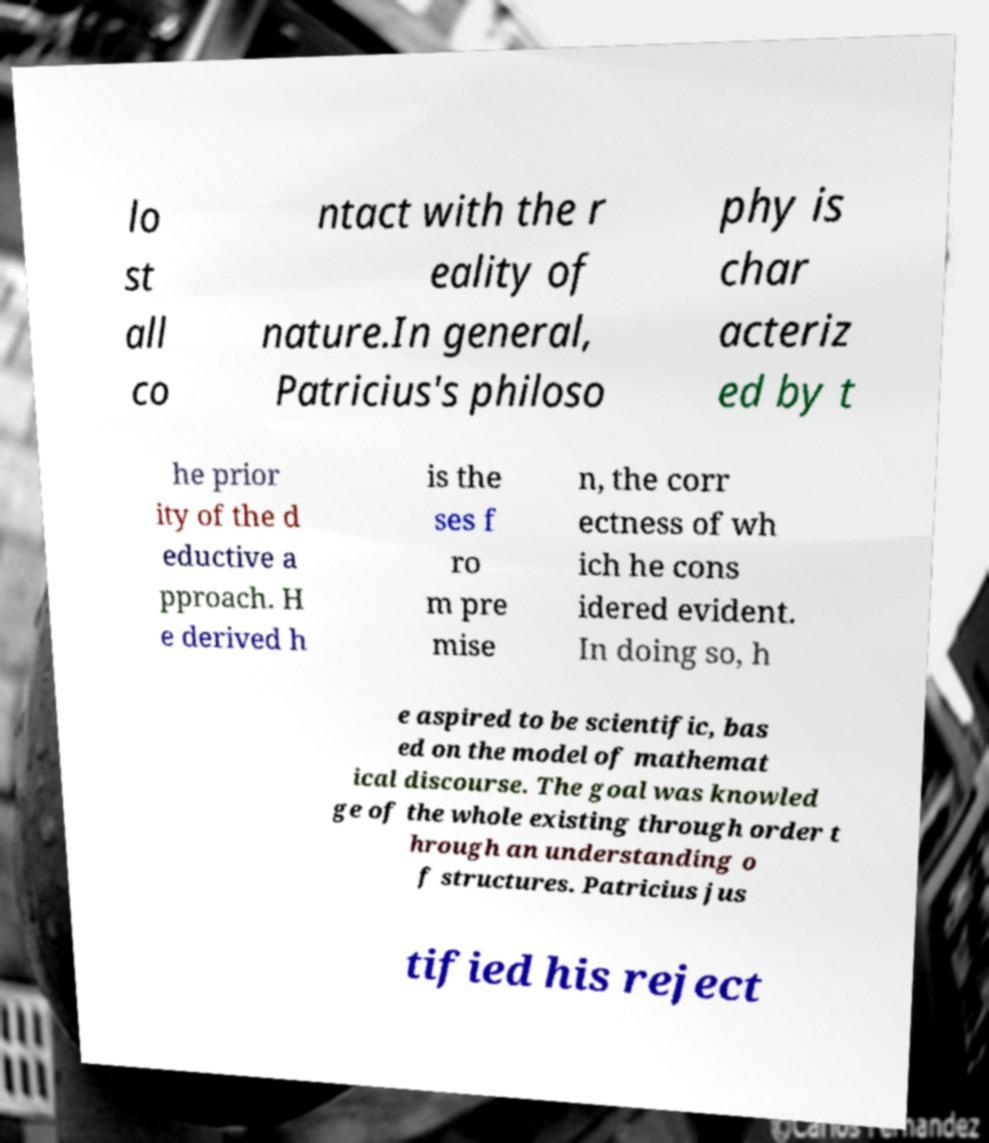I need the written content from this picture converted into text. Can you do that? lo st all co ntact with the r eality of nature.In general, Patricius's philoso phy is char acteriz ed by t he prior ity of the d eductive a pproach. H e derived h is the ses f ro m pre mise n, the corr ectness of wh ich he cons idered evident. In doing so, h e aspired to be scientific, bas ed on the model of mathemat ical discourse. The goal was knowled ge of the whole existing through order t hrough an understanding o f structures. Patricius jus tified his reject 